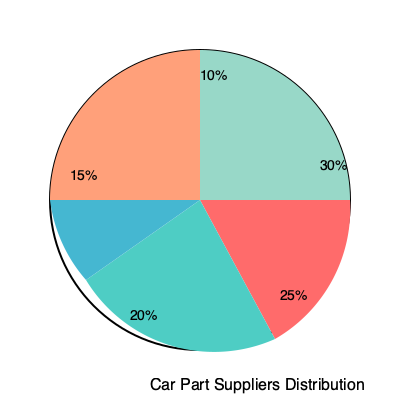As a car dealership owner, you're analyzing the distribution of your car part suppliers. The pie chart shows the percentage breakdown of your suppliers. If you currently work with 80 suppliers in total, how many suppliers would you need to add to increase the number of suppliers in the largest category by 25%? Let's approach this step-by-step:

1. Identify the largest category:
   The largest slice of the pie chart is 30%.

2. Calculate the current number of suppliers in the largest category:
   $30\% \text{ of } 80 = 0.30 \times 80 = 24$ suppliers

3. Calculate a 25% increase in the largest category:
   $25\% \text{ of } 24 = 0.25 \times 24 = 6$ additional suppliers

4. The new total for the largest category would be:
   $24 + 6 = 30$ suppliers

5. Calculate the new total number of suppliers:
   Let $x$ be the new total number of suppliers.
   The largest category should still represent 30% of the total:
   $\frac{30}{x} = 30\% = 0.30$

6. Solve for $x$:
   $30 = 0.30x$
   $x = \frac{30}{0.30} = 100$

7. Calculate the number of suppliers to add:
   $100 - 80 = 20$ suppliers

Therefore, you need to add 20 suppliers to increase the number in the largest category by 25% while maintaining its 30% share of the total.
Answer: 20 suppliers 